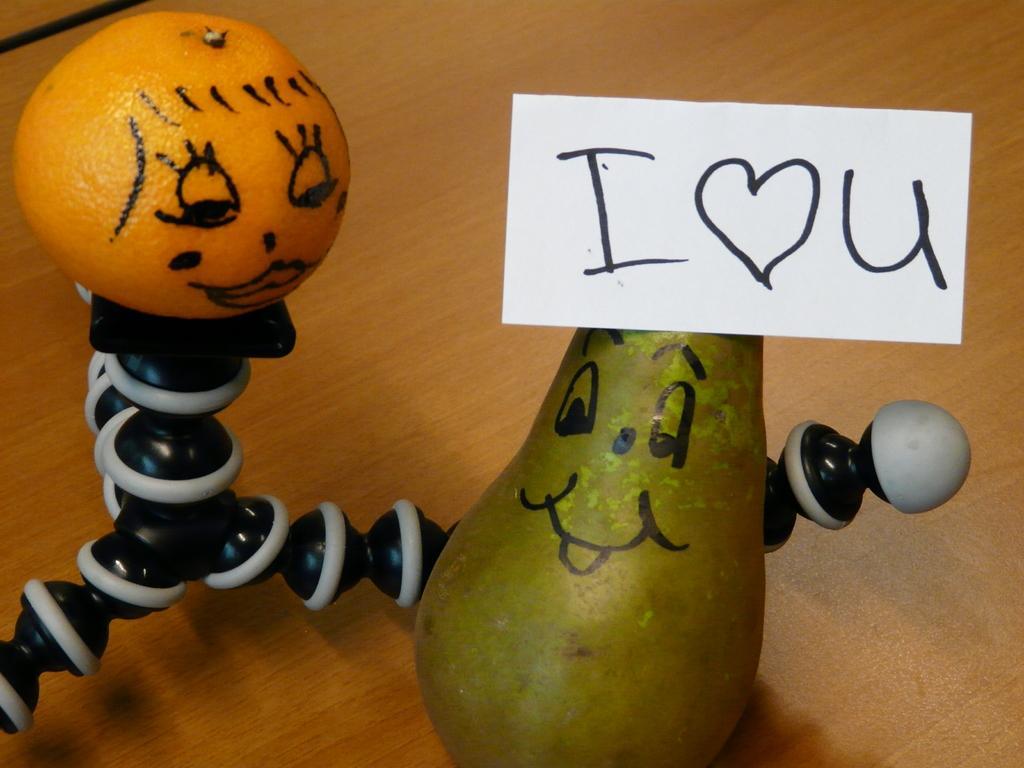Describe this image in one or two sentences. In this image there fruits on the fruits there is some drawing and there is one board, on the right side. On the board there is some text, on the left side there is some object. At the bottom there is a wooden table. 